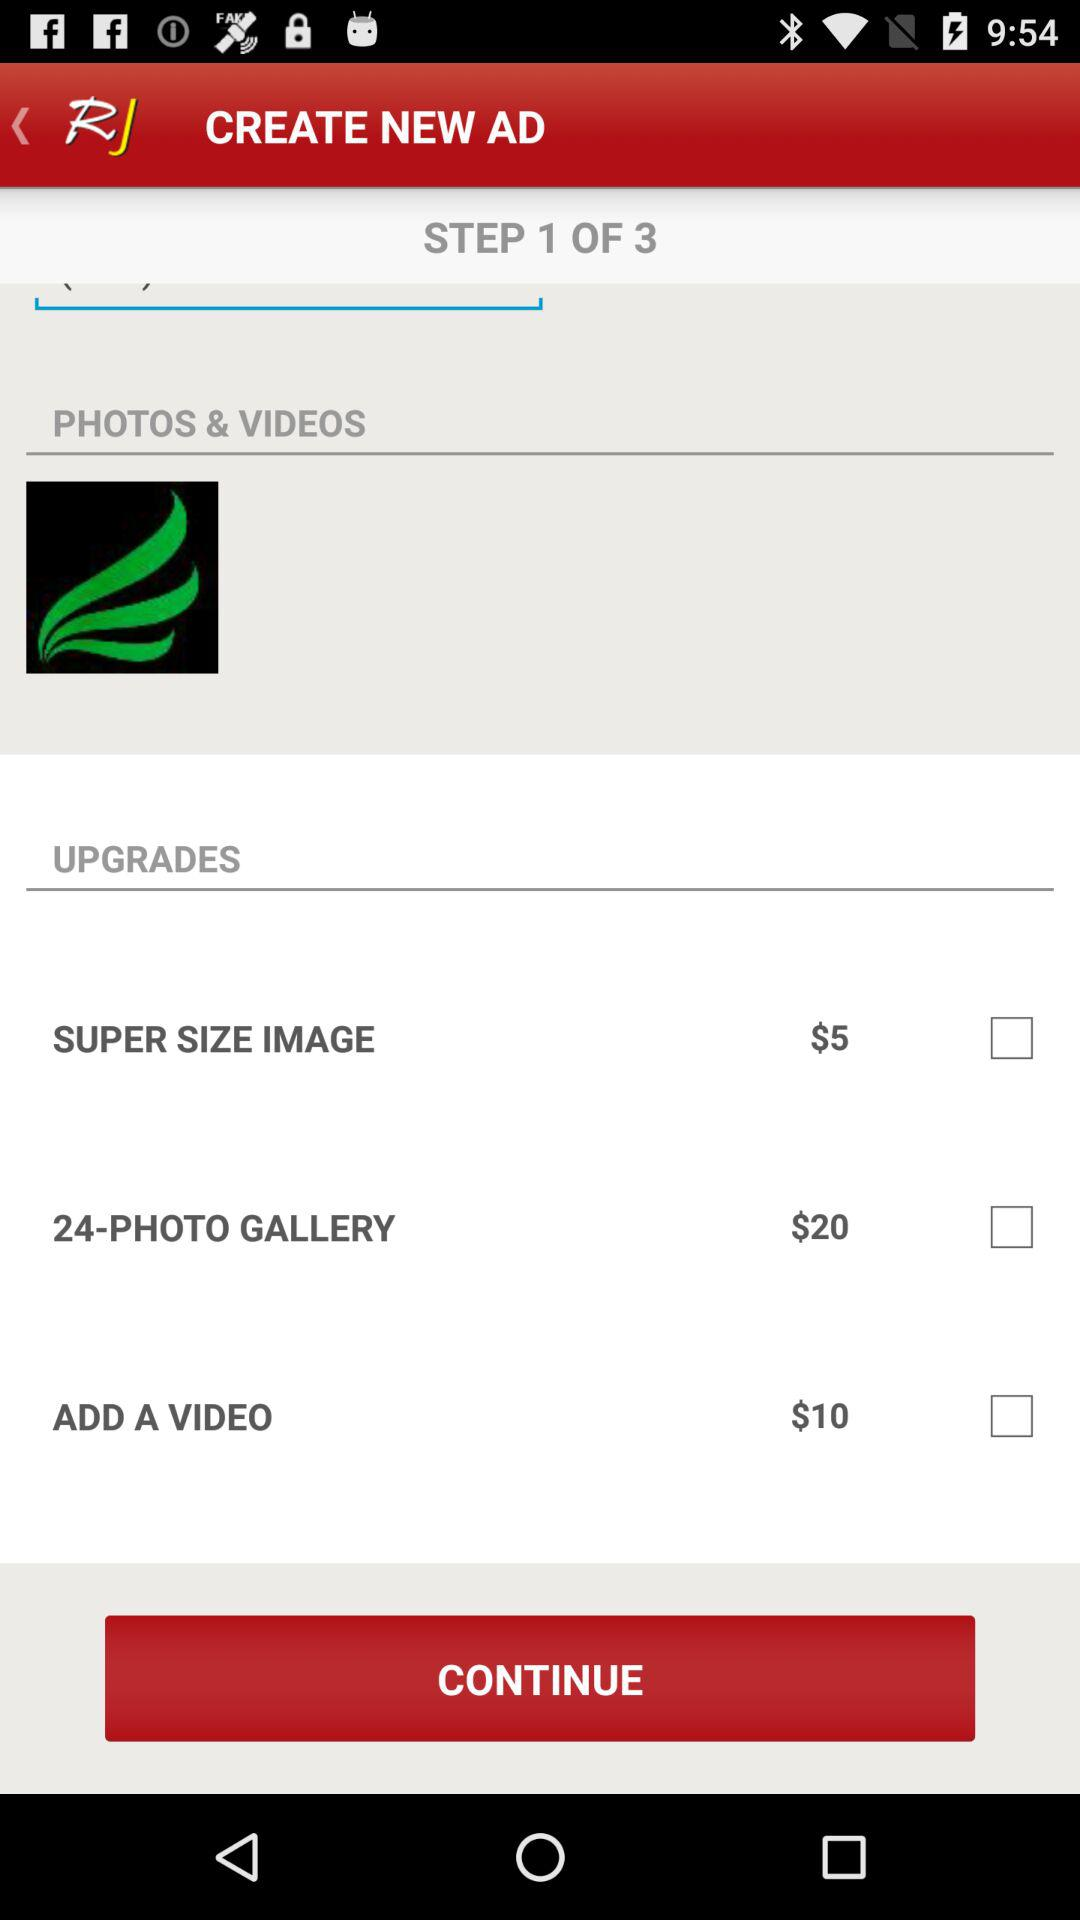What is the total number of steps? The total number of steps is 3. 